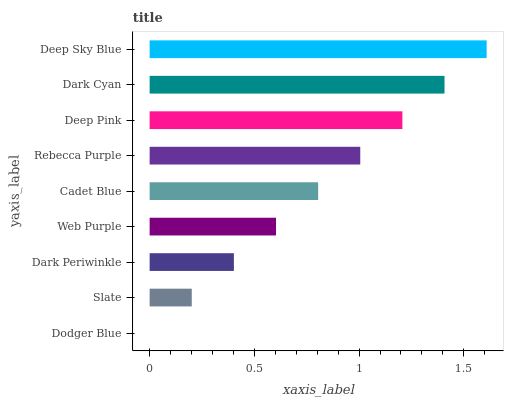Is Dodger Blue the minimum?
Answer yes or no. Yes. Is Deep Sky Blue the maximum?
Answer yes or no. Yes. Is Slate the minimum?
Answer yes or no. No. Is Slate the maximum?
Answer yes or no. No. Is Slate greater than Dodger Blue?
Answer yes or no. Yes. Is Dodger Blue less than Slate?
Answer yes or no. Yes. Is Dodger Blue greater than Slate?
Answer yes or no. No. Is Slate less than Dodger Blue?
Answer yes or no. No. Is Cadet Blue the high median?
Answer yes or no. Yes. Is Cadet Blue the low median?
Answer yes or no. Yes. Is Dark Periwinkle the high median?
Answer yes or no. No. Is Web Purple the low median?
Answer yes or no. No. 